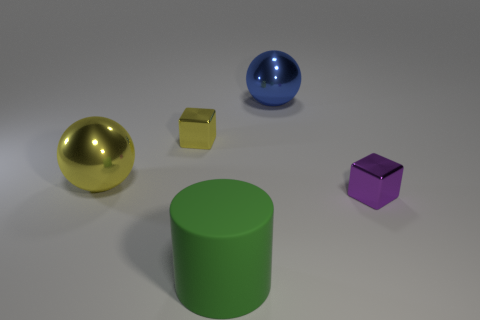Are there fewer big blue balls than cyan shiny things?
Your answer should be very brief. No. There is a large sphere right of the large green matte cylinder; is it the same color as the big matte object?
Your answer should be very brief. No. What number of blue spheres are on the right side of the large green object in front of the small cube that is to the right of the big matte cylinder?
Offer a terse response. 1. There is a tiny yellow cube; how many large green things are behind it?
Offer a very short reply. 0. What is the color of the other large shiny object that is the same shape as the blue thing?
Give a very brief answer. Yellow. The thing that is both right of the large rubber cylinder and in front of the blue metal thing is made of what material?
Provide a short and direct response. Metal. Do the metal cube that is to the right of the green thing and the green matte cylinder have the same size?
Ensure brevity in your answer.  No. What is the material of the large green cylinder?
Your answer should be very brief. Rubber. There is a sphere in front of the large blue metallic object; what color is it?
Give a very brief answer. Yellow. How many large objects are yellow shiny things or blue balls?
Make the answer very short. 2. 